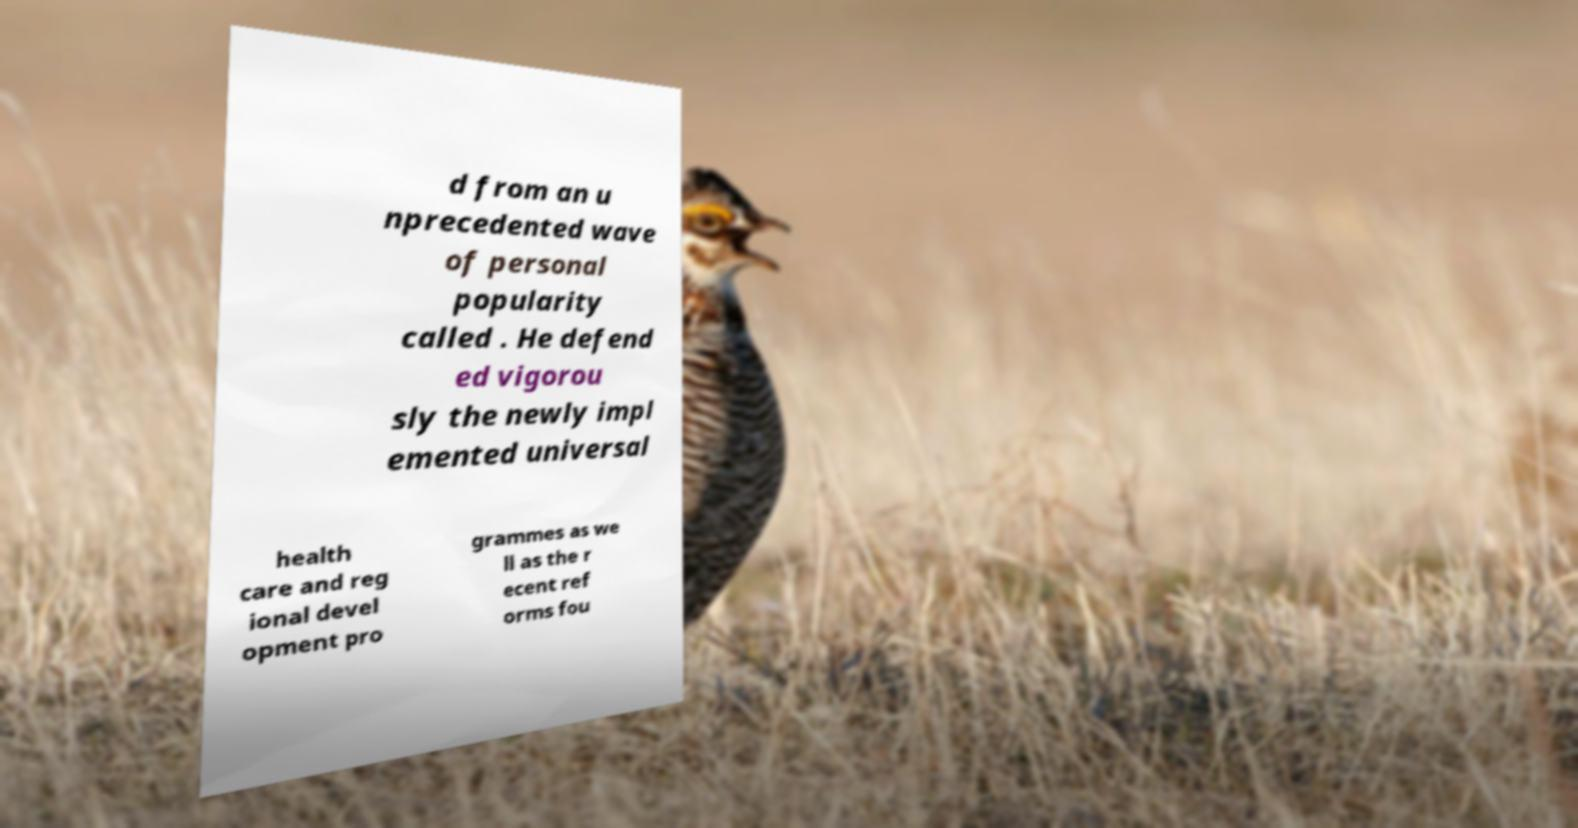There's text embedded in this image that I need extracted. Can you transcribe it verbatim? d from an u nprecedented wave of personal popularity called . He defend ed vigorou sly the newly impl emented universal health care and reg ional devel opment pro grammes as we ll as the r ecent ref orms fou 